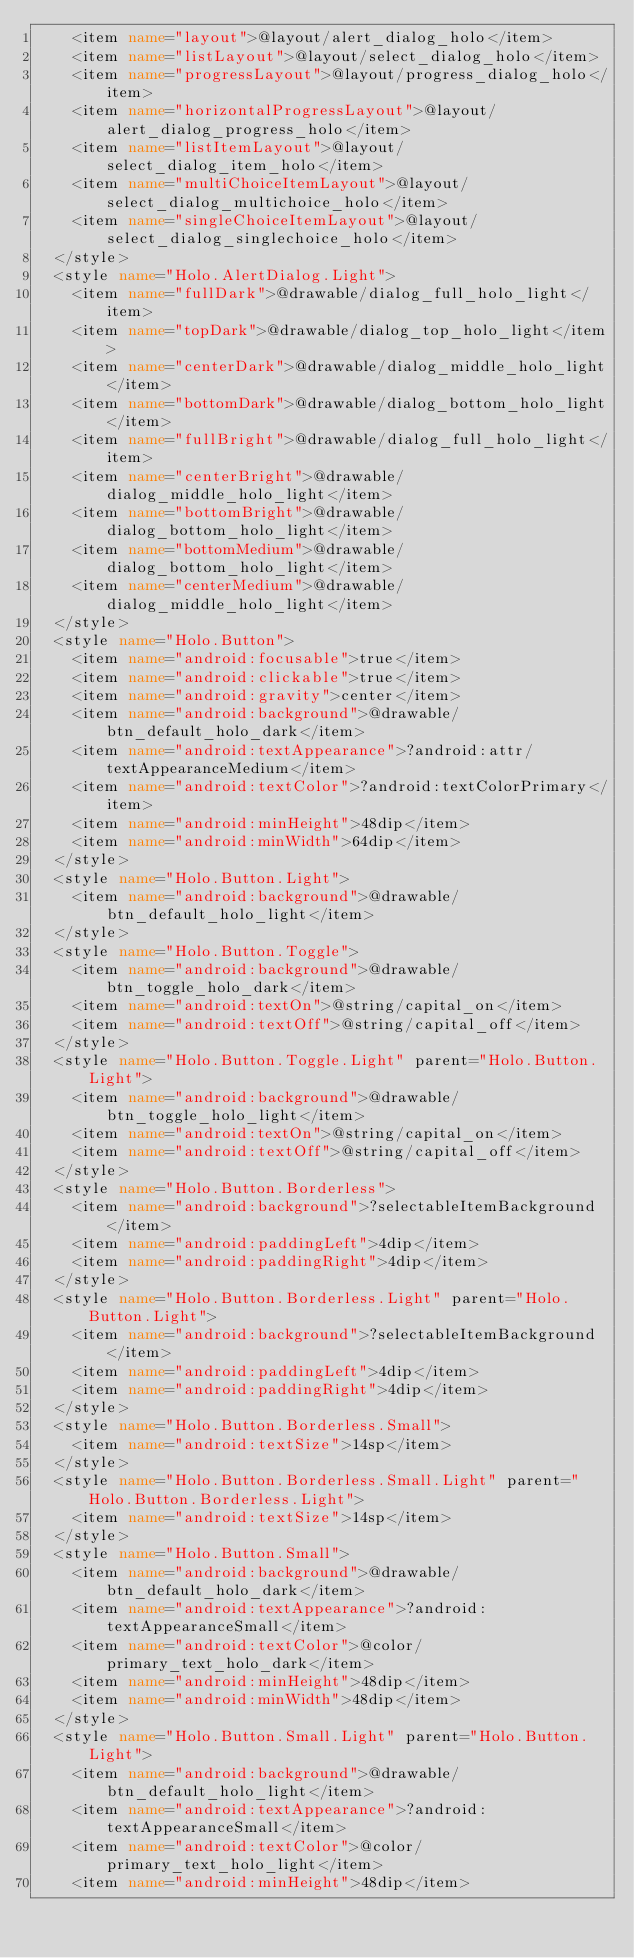Convert code to text. <code><loc_0><loc_0><loc_500><loc_500><_XML_>    <item name="layout">@layout/alert_dialog_holo</item>
    <item name="listLayout">@layout/select_dialog_holo</item>
    <item name="progressLayout">@layout/progress_dialog_holo</item>
    <item name="horizontalProgressLayout">@layout/alert_dialog_progress_holo</item>
    <item name="listItemLayout">@layout/select_dialog_item_holo</item>
    <item name="multiChoiceItemLayout">@layout/select_dialog_multichoice_holo</item>
    <item name="singleChoiceItemLayout">@layout/select_dialog_singlechoice_holo</item>
  </style>
  <style name="Holo.AlertDialog.Light">
    <item name="fullDark">@drawable/dialog_full_holo_light</item>
    <item name="topDark">@drawable/dialog_top_holo_light</item>
    <item name="centerDark">@drawable/dialog_middle_holo_light</item>
    <item name="bottomDark">@drawable/dialog_bottom_holo_light</item>
    <item name="fullBright">@drawable/dialog_full_holo_light</item>
    <item name="centerBright">@drawable/dialog_middle_holo_light</item>
    <item name="bottomBright">@drawable/dialog_bottom_holo_light</item>
    <item name="bottomMedium">@drawable/dialog_bottom_holo_light</item>
    <item name="centerMedium">@drawable/dialog_middle_holo_light</item>
  </style>
  <style name="Holo.Button">
    <item name="android:focusable">true</item>
    <item name="android:clickable">true</item>
    <item name="android:gravity">center</item>
    <item name="android:background">@drawable/btn_default_holo_dark</item>
    <item name="android:textAppearance">?android:attr/textAppearanceMedium</item>
    <item name="android:textColor">?android:textColorPrimary</item>
    <item name="android:minHeight">48dip</item>
    <item name="android:minWidth">64dip</item>
  </style>
  <style name="Holo.Button.Light">
    <item name="android:background">@drawable/btn_default_holo_light</item>
  </style>
  <style name="Holo.Button.Toggle">
    <item name="android:background">@drawable/btn_toggle_holo_dark</item>
    <item name="android:textOn">@string/capital_on</item>
    <item name="android:textOff">@string/capital_off</item>
  </style>
  <style name="Holo.Button.Toggle.Light" parent="Holo.Button.Light">
    <item name="android:background">@drawable/btn_toggle_holo_light</item>
    <item name="android:textOn">@string/capital_on</item>
    <item name="android:textOff">@string/capital_off</item>
  </style>
  <style name="Holo.Button.Borderless">
    <item name="android:background">?selectableItemBackground</item>
    <item name="android:paddingLeft">4dip</item>
    <item name="android:paddingRight">4dip</item>
  </style>
  <style name="Holo.Button.Borderless.Light" parent="Holo.Button.Light">
    <item name="android:background">?selectableItemBackground</item>
    <item name="android:paddingLeft">4dip</item>
    <item name="android:paddingRight">4dip</item>
  </style>
  <style name="Holo.Button.Borderless.Small">
    <item name="android:textSize">14sp</item>
  </style>
  <style name="Holo.Button.Borderless.Small.Light" parent="Holo.Button.Borderless.Light">
    <item name="android:textSize">14sp</item>
  </style>
  <style name="Holo.Button.Small">
    <item name="android:background">@drawable/btn_default_holo_dark</item>
    <item name="android:textAppearance">?android:textAppearanceSmall</item>
    <item name="android:textColor">@color/primary_text_holo_dark</item>
    <item name="android:minHeight">48dip</item>
    <item name="android:minWidth">48dip</item>
  </style>
  <style name="Holo.Button.Small.Light" parent="Holo.Button.Light">
    <item name="android:background">@drawable/btn_default_holo_light</item>
    <item name="android:textAppearance">?android:textAppearanceSmall</item>
    <item name="android:textColor">@color/primary_text_holo_light</item>
    <item name="android:minHeight">48dip</item></code> 